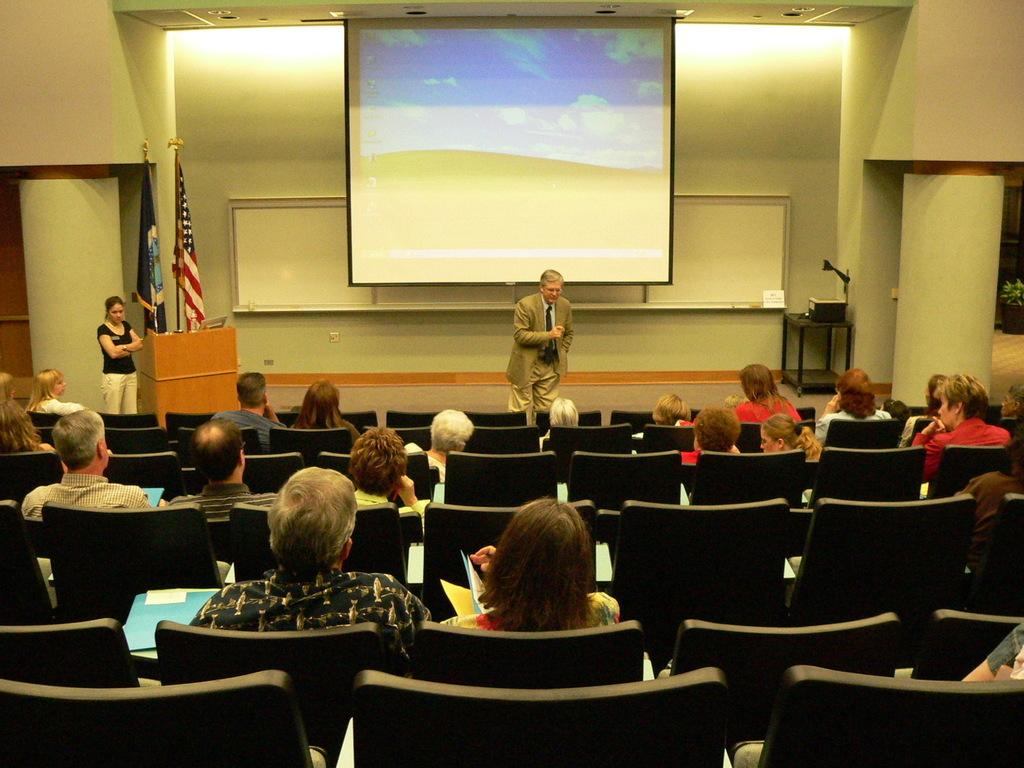What are the people in the image doing? There are many people sitting on chairs in the image. Can you describe the person standing in the image? There is a person standing at the back in the image. What object is present in the image that is typically used for speeches or presentations? There is a podium in the image. How many flags can be seen in the image? There are two flags in the image. What is visible in the background of the image? There is a wall and a screen in the background of the image. How many children are playing with the duck in the image? There are no children or ducks present in the image. What type of cracker is being passed around among the people in the image? There is no cracker present in the image. 